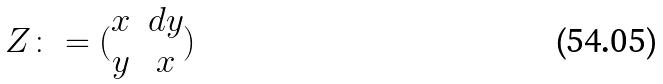<formula> <loc_0><loc_0><loc_500><loc_500>Z \colon = ( \begin{matrix} x & d y \\ y & x \end{matrix} )</formula> 